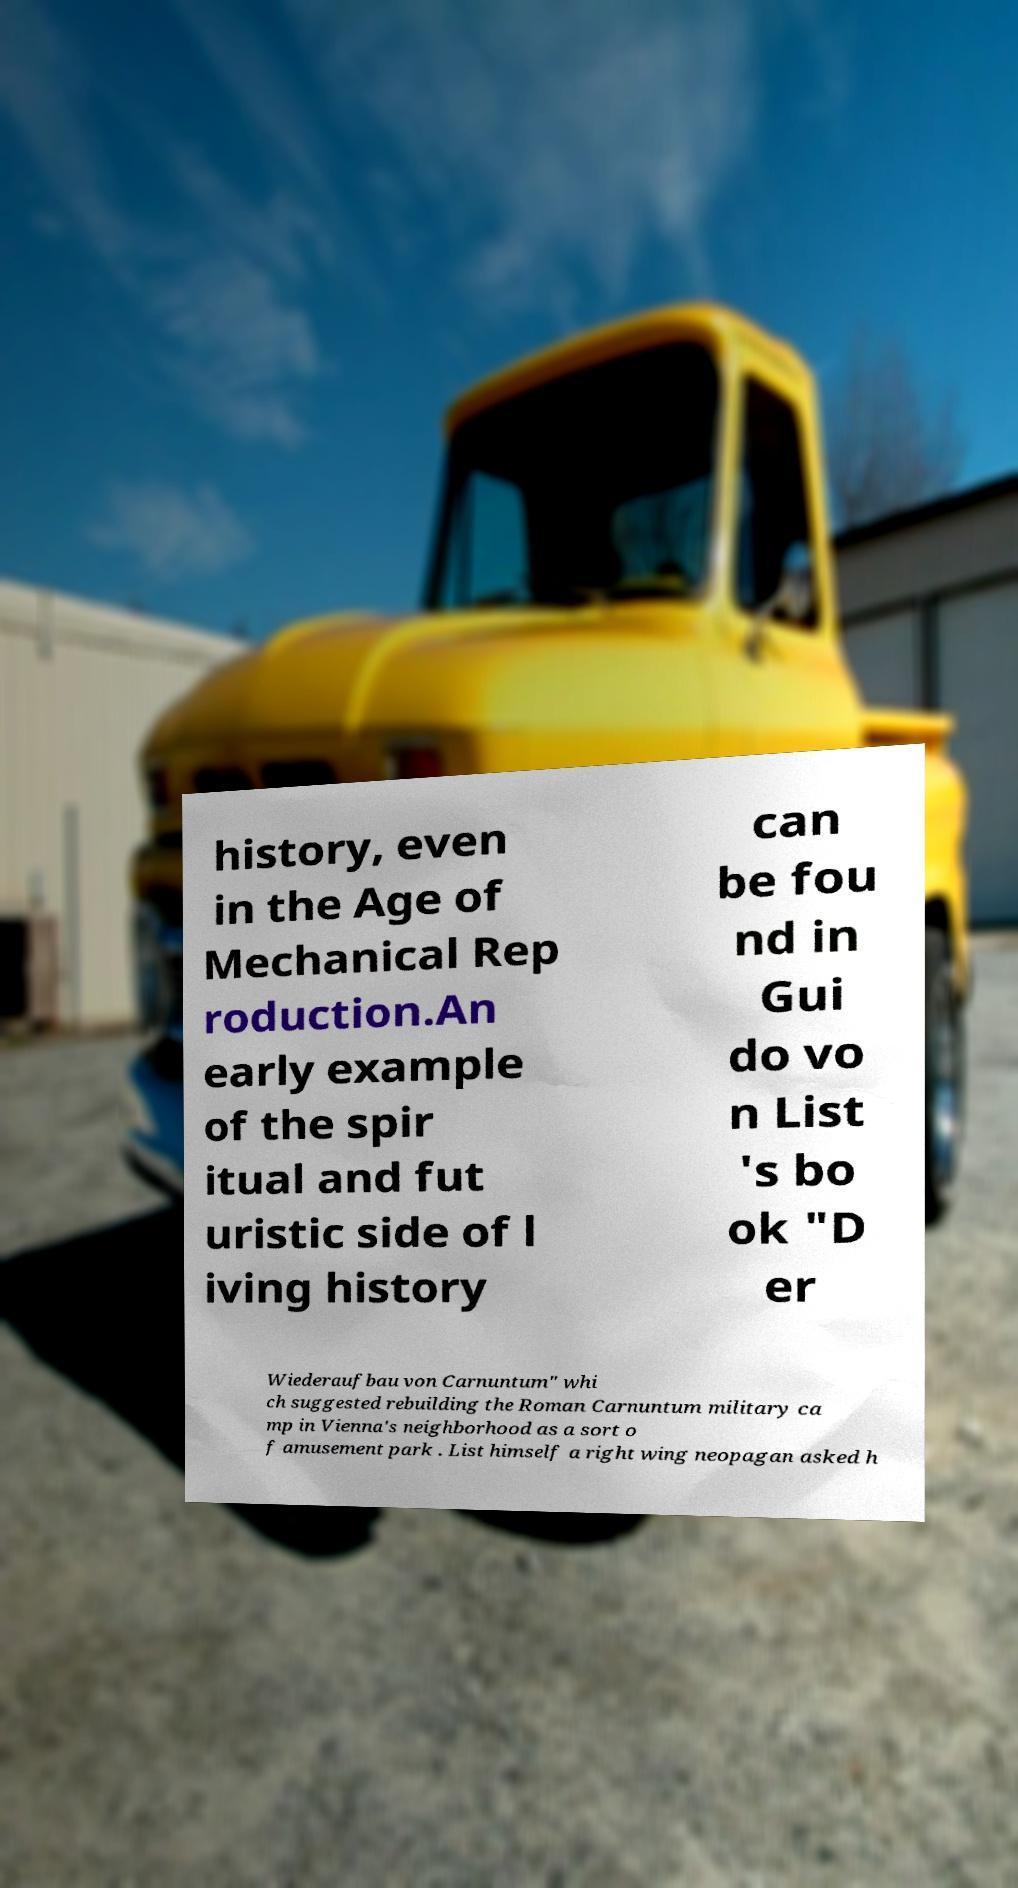What messages or text are displayed in this image? I need them in a readable, typed format. history, even in the Age of Mechanical Rep roduction.An early example of the spir itual and fut uristic side of l iving history can be fou nd in Gui do vo n List 's bo ok "D er Wiederaufbau von Carnuntum" whi ch suggested rebuilding the Roman Carnuntum military ca mp in Vienna's neighborhood as a sort o f amusement park . List himself a right wing neopagan asked h 